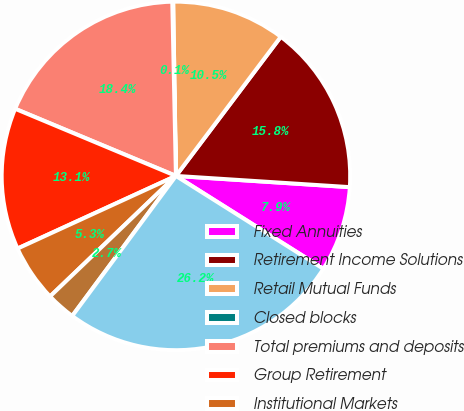Convert chart to OTSL. <chart><loc_0><loc_0><loc_500><loc_500><pie_chart><fcel>Fixed Annuities<fcel>Retirement Income Solutions<fcel>Retail Mutual Funds<fcel>Closed blocks<fcel>Total premiums and deposits<fcel>Group Retirement<fcel>Institutional Markets<fcel>Group Benefits<fcel>Total Life and Retirement<nl><fcel>7.92%<fcel>15.75%<fcel>10.53%<fcel>0.08%<fcel>18.37%<fcel>13.14%<fcel>5.31%<fcel>2.7%<fcel>26.2%<nl></chart> 